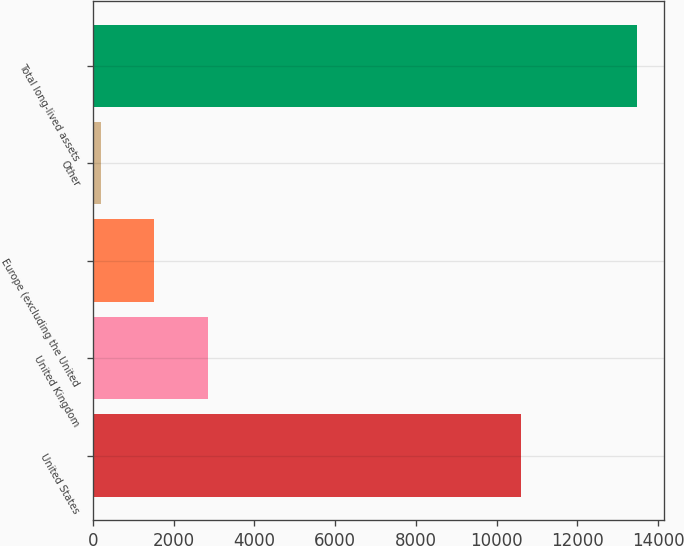<chart> <loc_0><loc_0><loc_500><loc_500><bar_chart><fcel>United States<fcel>United Kingdom<fcel>Europe (excluding the United<fcel>Other<fcel>Total long-lived assets<nl><fcel>10598<fcel>2853.2<fcel>1525.1<fcel>197<fcel>13478<nl></chart> 